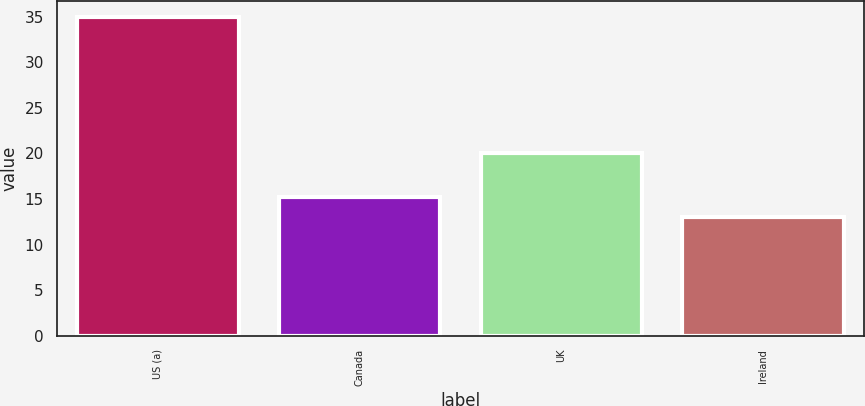Convert chart. <chart><loc_0><loc_0><loc_500><loc_500><bar_chart><fcel>US (a)<fcel>Canada<fcel>UK<fcel>Ireland<nl><fcel>35<fcel>15.2<fcel>20<fcel>13<nl></chart> 